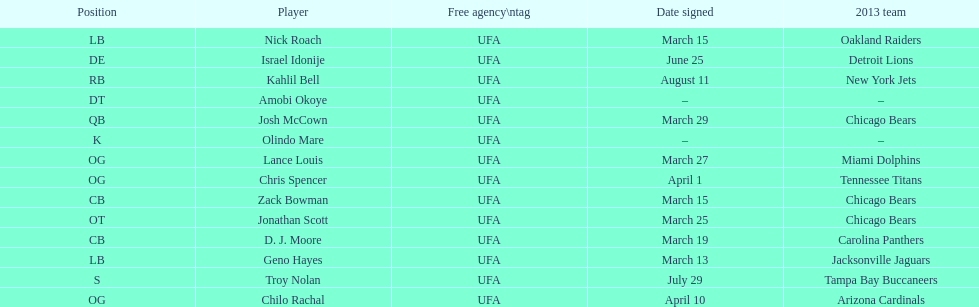Signed the same date as "april fools day". Chris Spencer. 